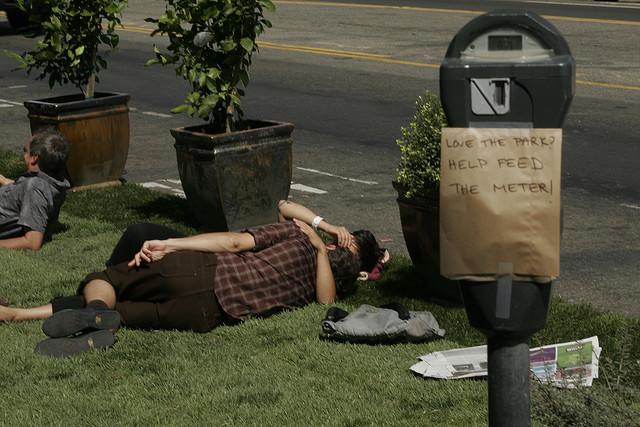What does the note on the parking meter say?
Be succinct. Love park? help feed meter!. Are the people sitting on a bench?
Give a very brief answer. No. How many people are laying on the grass?
Be succinct. 3. 